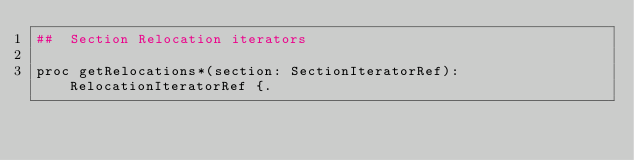<code> <loc_0><loc_0><loc_500><loc_500><_Nim_>##  Section Relocation iterators

proc getRelocations*(section: SectionIteratorRef): RelocationIteratorRef {.</code> 